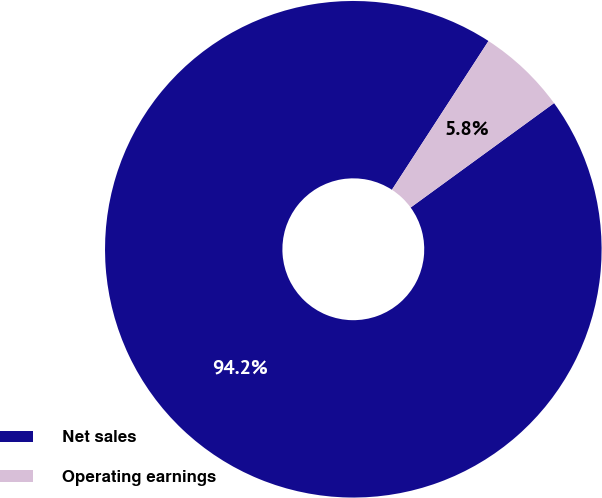Convert chart to OTSL. <chart><loc_0><loc_0><loc_500><loc_500><pie_chart><fcel>Net sales<fcel>Operating earnings<nl><fcel>94.18%<fcel>5.82%<nl></chart> 